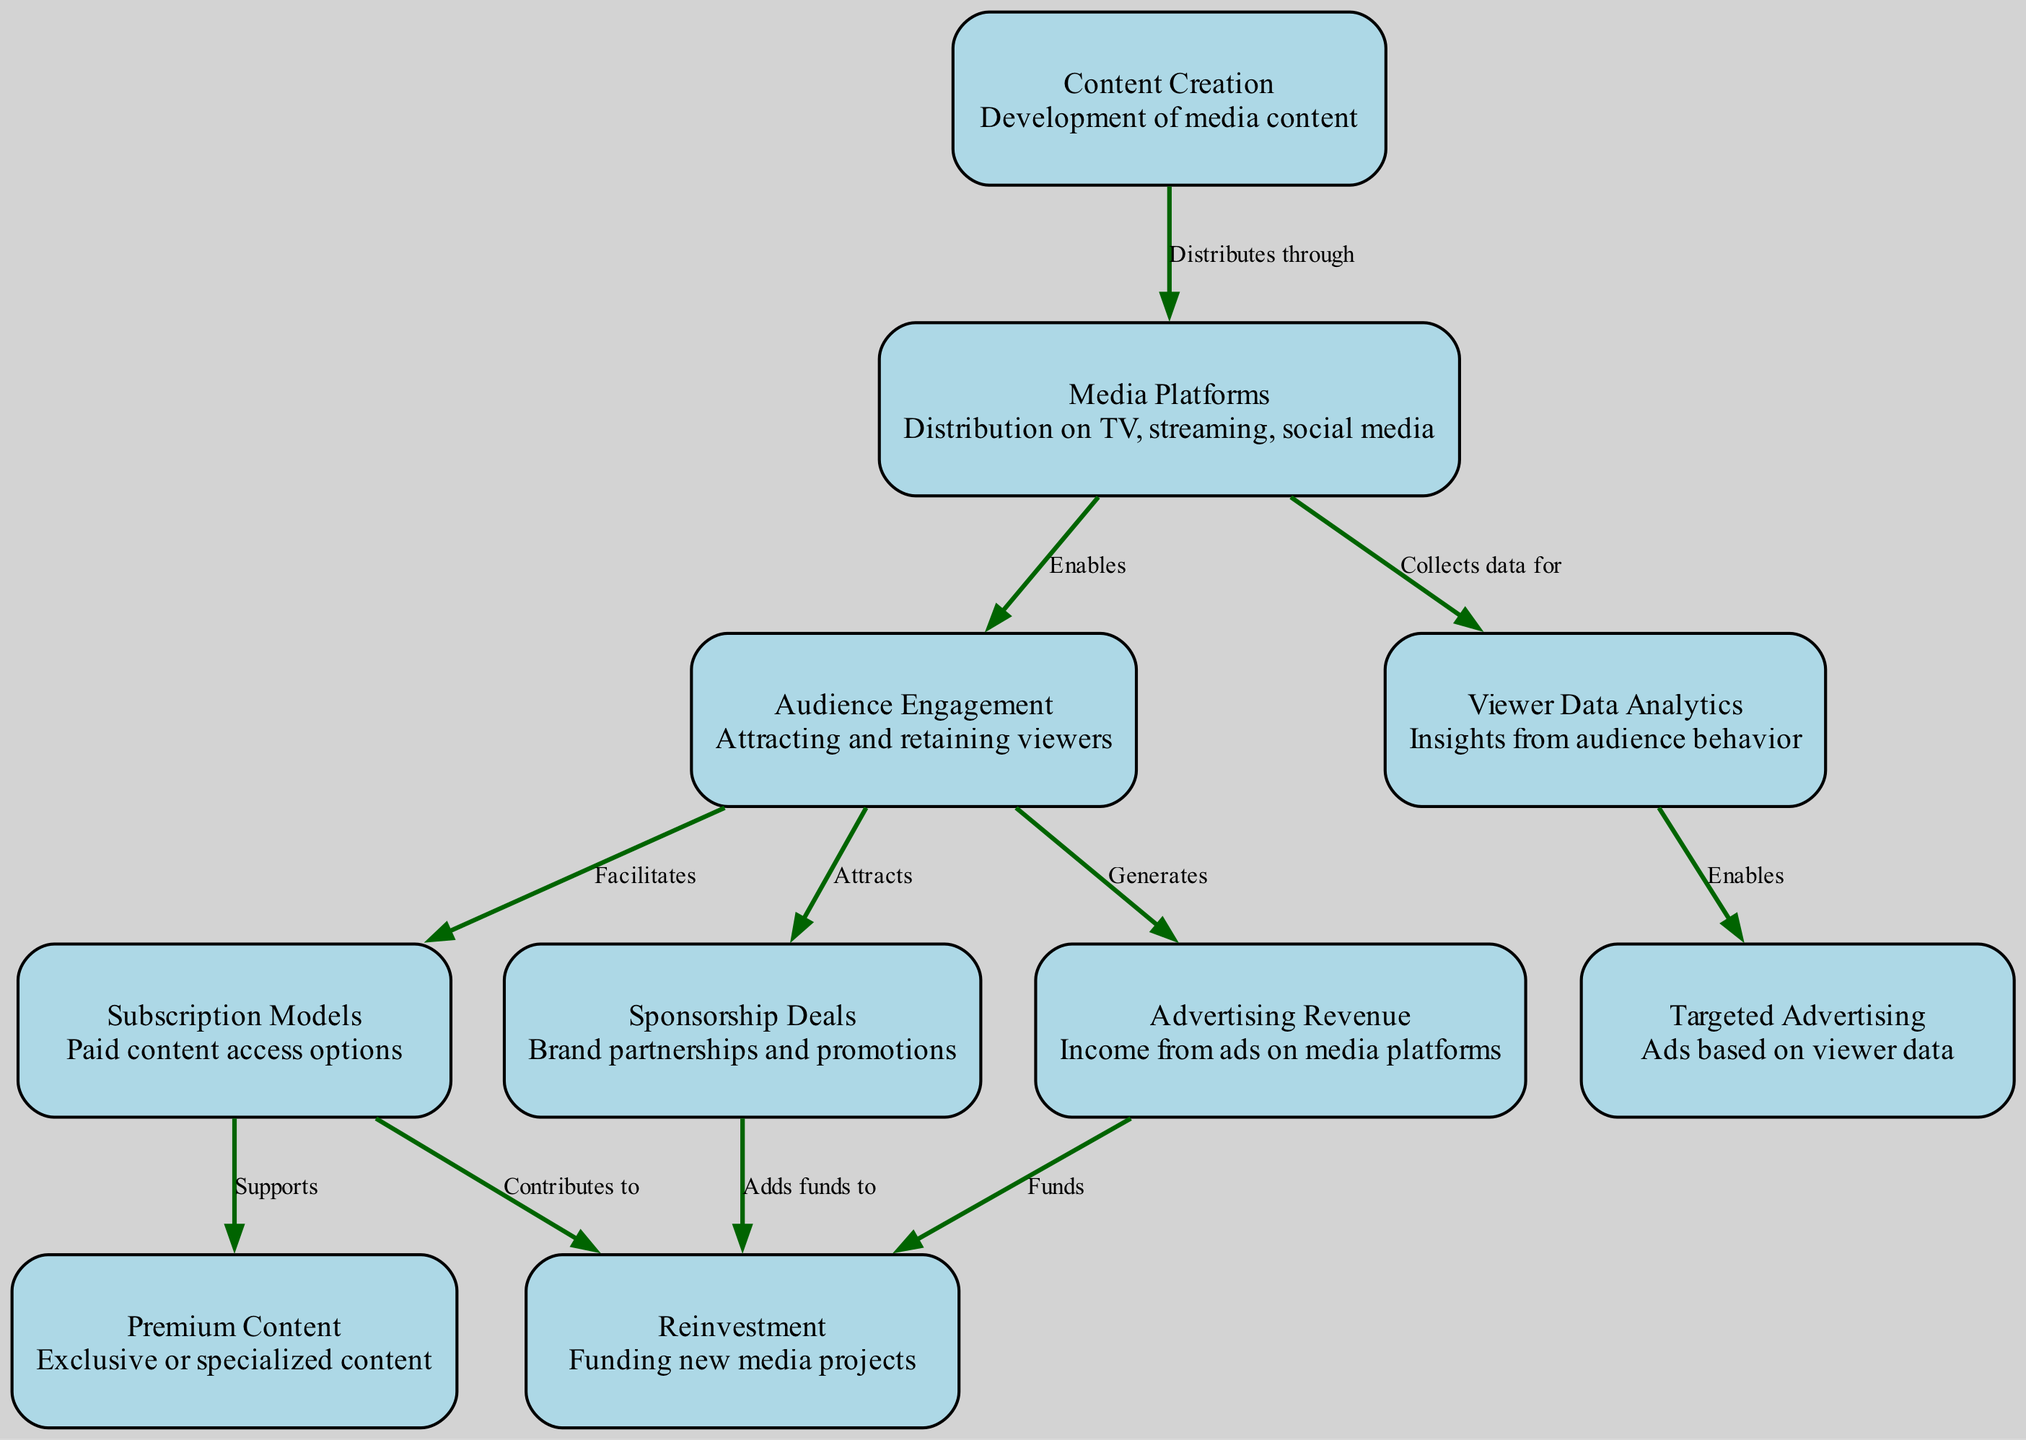What is the first node in the food chain? The first node in the food chain represents the initiation of the process and is labeled "Content Creation," which is where the development of media content takes place.
Answer: Content Creation How many nodes are present in the diagram? By counting each of the individual nodes defined in the data section, there are a total of 10 nodes that represent various aspects of the media monetization avenues.
Answer: 10 What type of revenue does "Audience Engagement" generate? The diagram indicates that "Audience Engagement" generates "Advertising Revenue," showcasing the direct connection between the two nodes that represent revenue generation from engaging viewers.
Answer: Advertising Revenue Which node collects data for "Targeted Advertising"? The flow indicates that the "Media Platforms" node is responsible for collecting data that enables "Targeted Advertising," highlighting the dependency between data collection and advertising strategies.
Answer: Media Platforms What do "Subscription Models" contribute to? The diagram outlines that "Subscription Models" contribute to "Reinvestment," indicating that the revenue from subscriptions is used to fund new projects in the media space.
Answer: Reinvestment How does "Viewer Data Analytics" influence advertising? According to the connections in the diagram, "Viewer Data Analytics" enables "Targeted Advertising," meaning that insights from audience behavior can be used to tailor advertisements to specific viewer segments.
Answer: Enables Which nodes can "Audience Engagement" facilitate? "Audience Engagement" facilitates both "Advertising Revenue" and "Subscription Models," indicating its critical role in generating revenue streams from multiple sources.
Answer: Advertising Revenue, Subscription Models What supports "Premium Content"? The diagram states that "Subscription Models" support "Premium Content," illustrating that paid content access options aid in the creation and access to exclusive content offerings in the media landscape.
Answer: Subscription Models Which node attracts sponsorship deals? From the flow of the diagram, it is clear that "Audience Engagement" attracts sponsorship deals, emphasizing the importance of viewer interaction in drawing brand partnerships.
Answer: Audience Engagement What adds funds to reinvestment? The diagram indicates that "Sponsorship Deals" adds funds to "Reinvestment," showing how brand partnerships and promotions contribute financially to new media projects.
Answer: Sponsorship Deals 